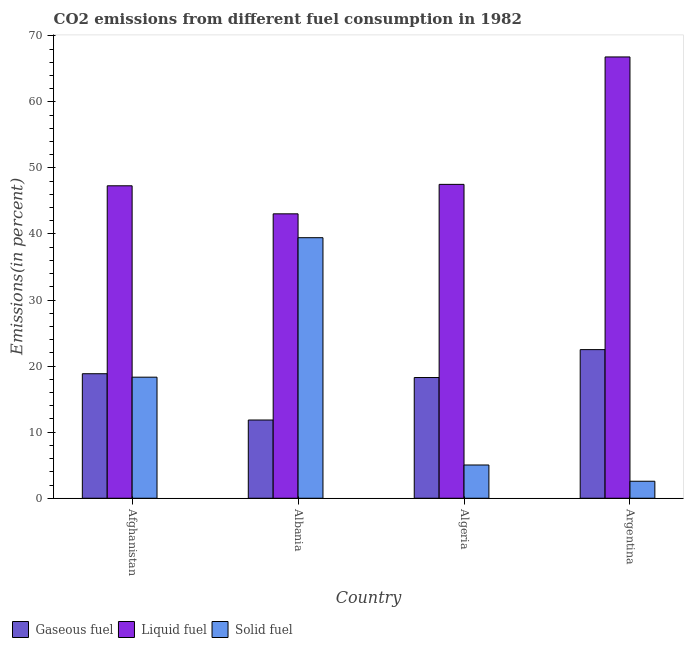How many groups of bars are there?
Provide a succinct answer. 4. Are the number of bars on each tick of the X-axis equal?
Make the answer very short. Yes. How many bars are there on the 3rd tick from the left?
Keep it short and to the point. 3. How many bars are there on the 1st tick from the right?
Your answer should be very brief. 3. What is the label of the 4th group of bars from the left?
Provide a succinct answer. Argentina. What is the percentage of liquid fuel emission in Algeria?
Make the answer very short. 47.51. Across all countries, what is the maximum percentage of gaseous fuel emission?
Offer a very short reply. 22.5. Across all countries, what is the minimum percentage of liquid fuel emission?
Your response must be concise. 43.05. In which country was the percentage of solid fuel emission maximum?
Offer a very short reply. Albania. In which country was the percentage of liquid fuel emission minimum?
Provide a succinct answer. Albania. What is the total percentage of liquid fuel emission in the graph?
Your answer should be compact. 204.66. What is the difference between the percentage of liquid fuel emission in Albania and that in Algeria?
Offer a terse response. -4.46. What is the difference between the percentage of liquid fuel emission in Argentina and the percentage of gaseous fuel emission in Albania?
Keep it short and to the point. 54.96. What is the average percentage of gaseous fuel emission per country?
Give a very brief answer. 17.87. What is the difference between the percentage of solid fuel emission and percentage of gaseous fuel emission in Albania?
Offer a terse response. 27.6. What is the ratio of the percentage of gaseous fuel emission in Afghanistan to that in Argentina?
Keep it short and to the point. 0.84. Is the percentage of liquid fuel emission in Albania less than that in Algeria?
Offer a terse response. Yes. What is the difference between the highest and the second highest percentage of solid fuel emission?
Ensure brevity in your answer.  21.11. What is the difference between the highest and the lowest percentage of solid fuel emission?
Your answer should be compact. 36.86. In how many countries, is the percentage of solid fuel emission greater than the average percentage of solid fuel emission taken over all countries?
Give a very brief answer. 2. What does the 2nd bar from the left in Algeria represents?
Offer a terse response. Liquid fuel. What does the 2nd bar from the right in Algeria represents?
Make the answer very short. Liquid fuel. How many bars are there?
Your response must be concise. 12. How many countries are there in the graph?
Make the answer very short. 4. Does the graph contain grids?
Your answer should be very brief. No. Where does the legend appear in the graph?
Offer a terse response. Bottom left. How are the legend labels stacked?
Your answer should be compact. Horizontal. What is the title of the graph?
Provide a short and direct response. CO2 emissions from different fuel consumption in 1982. Does "Infant(female)" appear as one of the legend labels in the graph?
Keep it short and to the point. No. What is the label or title of the X-axis?
Offer a terse response. Country. What is the label or title of the Y-axis?
Ensure brevity in your answer.  Emissions(in percent). What is the Emissions(in percent) in Gaseous fuel in Afghanistan?
Ensure brevity in your answer.  18.85. What is the Emissions(in percent) in Liquid fuel in Afghanistan?
Your answer should be compact. 47.29. What is the Emissions(in percent) in Solid fuel in Afghanistan?
Make the answer very short. 18.32. What is the Emissions(in percent) in Gaseous fuel in Albania?
Offer a terse response. 11.84. What is the Emissions(in percent) of Liquid fuel in Albania?
Provide a succinct answer. 43.05. What is the Emissions(in percent) in Solid fuel in Albania?
Your answer should be compact. 39.44. What is the Emissions(in percent) of Gaseous fuel in Algeria?
Your answer should be compact. 18.27. What is the Emissions(in percent) of Liquid fuel in Algeria?
Your answer should be compact. 47.51. What is the Emissions(in percent) of Solid fuel in Algeria?
Your response must be concise. 5.03. What is the Emissions(in percent) of Gaseous fuel in Argentina?
Give a very brief answer. 22.5. What is the Emissions(in percent) in Liquid fuel in Argentina?
Provide a short and direct response. 66.8. What is the Emissions(in percent) in Solid fuel in Argentina?
Offer a terse response. 2.57. Across all countries, what is the maximum Emissions(in percent) of Gaseous fuel?
Offer a terse response. 22.5. Across all countries, what is the maximum Emissions(in percent) in Liquid fuel?
Your answer should be compact. 66.8. Across all countries, what is the maximum Emissions(in percent) of Solid fuel?
Your answer should be very brief. 39.44. Across all countries, what is the minimum Emissions(in percent) of Gaseous fuel?
Your response must be concise. 11.84. Across all countries, what is the minimum Emissions(in percent) in Liquid fuel?
Ensure brevity in your answer.  43.05. Across all countries, what is the minimum Emissions(in percent) in Solid fuel?
Offer a terse response. 2.57. What is the total Emissions(in percent) of Gaseous fuel in the graph?
Provide a short and direct response. 71.46. What is the total Emissions(in percent) in Liquid fuel in the graph?
Keep it short and to the point. 204.66. What is the total Emissions(in percent) of Solid fuel in the graph?
Give a very brief answer. 65.37. What is the difference between the Emissions(in percent) of Gaseous fuel in Afghanistan and that in Albania?
Your answer should be very brief. 7.01. What is the difference between the Emissions(in percent) of Liquid fuel in Afghanistan and that in Albania?
Offer a very short reply. 4.24. What is the difference between the Emissions(in percent) of Solid fuel in Afghanistan and that in Albania?
Give a very brief answer. -21.11. What is the difference between the Emissions(in percent) of Gaseous fuel in Afghanistan and that in Algeria?
Provide a succinct answer. 0.57. What is the difference between the Emissions(in percent) in Liquid fuel in Afghanistan and that in Algeria?
Make the answer very short. -0.22. What is the difference between the Emissions(in percent) in Solid fuel in Afghanistan and that in Algeria?
Your answer should be compact. 13.29. What is the difference between the Emissions(in percent) of Gaseous fuel in Afghanistan and that in Argentina?
Make the answer very short. -3.65. What is the difference between the Emissions(in percent) of Liquid fuel in Afghanistan and that in Argentina?
Provide a succinct answer. -19.5. What is the difference between the Emissions(in percent) in Solid fuel in Afghanistan and that in Argentina?
Your answer should be compact. 15.75. What is the difference between the Emissions(in percent) of Gaseous fuel in Albania and that in Algeria?
Offer a terse response. -6.43. What is the difference between the Emissions(in percent) of Liquid fuel in Albania and that in Algeria?
Give a very brief answer. -4.46. What is the difference between the Emissions(in percent) of Solid fuel in Albania and that in Algeria?
Offer a very short reply. 34.4. What is the difference between the Emissions(in percent) of Gaseous fuel in Albania and that in Argentina?
Make the answer very short. -10.66. What is the difference between the Emissions(in percent) of Liquid fuel in Albania and that in Argentina?
Give a very brief answer. -23.75. What is the difference between the Emissions(in percent) of Solid fuel in Albania and that in Argentina?
Offer a terse response. 36.86. What is the difference between the Emissions(in percent) of Gaseous fuel in Algeria and that in Argentina?
Offer a very short reply. -4.22. What is the difference between the Emissions(in percent) in Liquid fuel in Algeria and that in Argentina?
Keep it short and to the point. -19.29. What is the difference between the Emissions(in percent) in Solid fuel in Algeria and that in Argentina?
Ensure brevity in your answer.  2.46. What is the difference between the Emissions(in percent) of Gaseous fuel in Afghanistan and the Emissions(in percent) of Liquid fuel in Albania?
Ensure brevity in your answer.  -24.2. What is the difference between the Emissions(in percent) in Gaseous fuel in Afghanistan and the Emissions(in percent) in Solid fuel in Albania?
Make the answer very short. -20.59. What is the difference between the Emissions(in percent) of Liquid fuel in Afghanistan and the Emissions(in percent) of Solid fuel in Albania?
Keep it short and to the point. 7.86. What is the difference between the Emissions(in percent) of Gaseous fuel in Afghanistan and the Emissions(in percent) of Liquid fuel in Algeria?
Ensure brevity in your answer.  -28.66. What is the difference between the Emissions(in percent) in Gaseous fuel in Afghanistan and the Emissions(in percent) in Solid fuel in Algeria?
Offer a terse response. 13.81. What is the difference between the Emissions(in percent) of Liquid fuel in Afghanistan and the Emissions(in percent) of Solid fuel in Algeria?
Your response must be concise. 42.26. What is the difference between the Emissions(in percent) in Gaseous fuel in Afghanistan and the Emissions(in percent) in Liquid fuel in Argentina?
Keep it short and to the point. -47.95. What is the difference between the Emissions(in percent) in Gaseous fuel in Afghanistan and the Emissions(in percent) in Solid fuel in Argentina?
Provide a succinct answer. 16.27. What is the difference between the Emissions(in percent) of Liquid fuel in Afghanistan and the Emissions(in percent) of Solid fuel in Argentina?
Ensure brevity in your answer.  44.72. What is the difference between the Emissions(in percent) in Gaseous fuel in Albania and the Emissions(in percent) in Liquid fuel in Algeria?
Your response must be concise. -35.67. What is the difference between the Emissions(in percent) in Gaseous fuel in Albania and the Emissions(in percent) in Solid fuel in Algeria?
Give a very brief answer. 6.81. What is the difference between the Emissions(in percent) in Liquid fuel in Albania and the Emissions(in percent) in Solid fuel in Algeria?
Ensure brevity in your answer.  38.02. What is the difference between the Emissions(in percent) of Gaseous fuel in Albania and the Emissions(in percent) of Liquid fuel in Argentina?
Your answer should be very brief. -54.96. What is the difference between the Emissions(in percent) in Gaseous fuel in Albania and the Emissions(in percent) in Solid fuel in Argentina?
Keep it short and to the point. 9.27. What is the difference between the Emissions(in percent) of Liquid fuel in Albania and the Emissions(in percent) of Solid fuel in Argentina?
Offer a terse response. 40.48. What is the difference between the Emissions(in percent) in Gaseous fuel in Algeria and the Emissions(in percent) in Liquid fuel in Argentina?
Your response must be concise. -48.52. What is the difference between the Emissions(in percent) of Gaseous fuel in Algeria and the Emissions(in percent) of Solid fuel in Argentina?
Provide a short and direct response. 15.7. What is the difference between the Emissions(in percent) in Liquid fuel in Algeria and the Emissions(in percent) in Solid fuel in Argentina?
Provide a short and direct response. 44.94. What is the average Emissions(in percent) of Gaseous fuel per country?
Your response must be concise. 17.87. What is the average Emissions(in percent) of Liquid fuel per country?
Your response must be concise. 51.16. What is the average Emissions(in percent) of Solid fuel per country?
Give a very brief answer. 16.34. What is the difference between the Emissions(in percent) of Gaseous fuel and Emissions(in percent) of Liquid fuel in Afghanistan?
Provide a succinct answer. -28.45. What is the difference between the Emissions(in percent) in Gaseous fuel and Emissions(in percent) in Solid fuel in Afghanistan?
Give a very brief answer. 0.52. What is the difference between the Emissions(in percent) of Liquid fuel and Emissions(in percent) of Solid fuel in Afghanistan?
Your answer should be very brief. 28.97. What is the difference between the Emissions(in percent) of Gaseous fuel and Emissions(in percent) of Liquid fuel in Albania?
Offer a very short reply. -31.21. What is the difference between the Emissions(in percent) of Gaseous fuel and Emissions(in percent) of Solid fuel in Albania?
Your response must be concise. -27.6. What is the difference between the Emissions(in percent) of Liquid fuel and Emissions(in percent) of Solid fuel in Albania?
Your answer should be very brief. 3.61. What is the difference between the Emissions(in percent) in Gaseous fuel and Emissions(in percent) in Liquid fuel in Algeria?
Offer a terse response. -29.24. What is the difference between the Emissions(in percent) in Gaseous fuel and Emissions(in percent) in Solid fuel in Algeria?
Offer a terse response. 13.24. What is the difference between the Emissions(in percent) in Liquid fuel and Emissions(in percent) in Solid fuel in Algeria?
Your answer should be compact. 42.48. What is the difference between the Emissions(in percent) of Gaseous fuel and Emissions(in percent) of Liquid fuel in Argentina?
Offer a very short reply. -44.3. What is the difference between the Emissions(in percent) of Gaseous fuel and Emissions(in percent) of Solid fuel in Argentina?
Ensure brevity in your answer.  19.92. What is the difference between the Emissions(in percent) of Liquid fuel and Emissions(in percent) of Solid fuel in Argentina?
Your answer should be compact. 64.22. What is the ratio of the Emissions(in percent) in Gaseous fuel in Afghanistan to that in Albania?
Provide a short and direct response. 1.59. What is the ratio of the Emissions(in percent) in Liquid fuel in Afghanistan to that in Albania?
Your answer should be very brief. 1.1. What is the ratio of the Emissions(in percent) of Solid fuel in Afghanistan to that in Albania?
Make the answer very short. 0.46. What is the ratio of the Emissions(in percent) in Gaseous fuel in Afghanistan to that in Algeria?
Make the answer very short. 1.03. What is the ratio of the Emissions(in percent) of Liquid fuel in Afghanistan to that in Algeria?
Your response must be concise. 1. What is the ratio of the Emissions(in percent) of Solid fuel in Afghanistan to that in Algeria?
Ensure brevity in your answer.  3.64. What is the ratio of the Emissions(in percent) in Gaseous fuel in Afghanistan to that in Argentina?
Keep it short and to the point. 0.84. What is the ratio of the Emissions(in percent) in Liquid fuel in Afghanistan to that in Argentina?
Your response must be concise. 0.71. What is the ratio of the Emissions(in percent) in Solid fuel in Afghanistan to that in Argentina?
Your answer should be very brief. 7.12. What is the ratio of the Emissions(in percent) in Gaseous fuel in Albania to that in Algeria?
Your answer should be compact. 0.65. What is the ratio of the Emissions(in percent) in Liquid fuel in Albania to that in Algeria?
Provide a short and direct response. 0.91. What is the ratio of the Emissions(in percent) in Solid fuel in Albania to that in Algeria?
Provide a short and direct response. 7.84. What is the ratio of the Emissions(in percent) in Gaseous fuel in Albania to that in Argentina?
Your answer should be very brief. 0.53. What is the ratio of the Emissions(in percent) of Liquid fuel in Albania to that in Argentina?
Give a very brief answer. 0.64. What is the ratio of the Emissions(in percent) of Solid fuel in Albania to that in Argentina?
Keep it short and to the point. 15.32. What is the ratio of the Emissions(in percent) of Gaseous fuel in Algeria to that in Argentina?
Make the answer very short. 0.81. What is the ratio of the Emissions(in percent) in Liquid fuel in Algeria to that in Argentina?
Provide a succinct answer. 0.71. What is the ratio of the Emissions(in percent) in Solid fuel in Algeria to that in Argentina?
Give a very brief answer. 1.96. What is the difference between the highest and the second highest Emissions(in percent) in Gaseous fuel?
Give a very brief answer. 3.65. What is the difference between the highest and the second highest Emissions(in percent) in Liquid fuel?
Offer a terse response. 19.29. What is the difference between the highest and the second highest Emissions(in percent) of Solid fuel?
Make the answer very short. 21.11. What is the difference between the highest and the lowest Emissions(in percent) in Gaseous fuel?
Your response must be concise. 10.66. What is the difference between the highest and the lowest Emissions(in percent) of Liquid fuel?
Provide a succinct answer. 23.75. What is the difference between the highest and the lowest Emissions(in percent) of Solid fuel?
Provide a succinct answer. 36.86. 